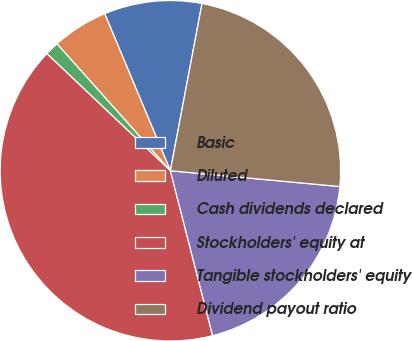Convert chart to OTSL. <chart><loc_0><loc_0><loc_500><loc_500><pie_chart><fcel>Basic<fcel>Diluted<fcel>Cash dividends declared<fcel>Stockholders' equity at<fcel>Tangible stockholders' equity<fcel>Dividend payout ratio<nl><fcel>9.28%<fcel>5.3%<fcel>1.32%<fcel>41.07%<fcel>19.53%<fcel>23.5%<nl></chart> 